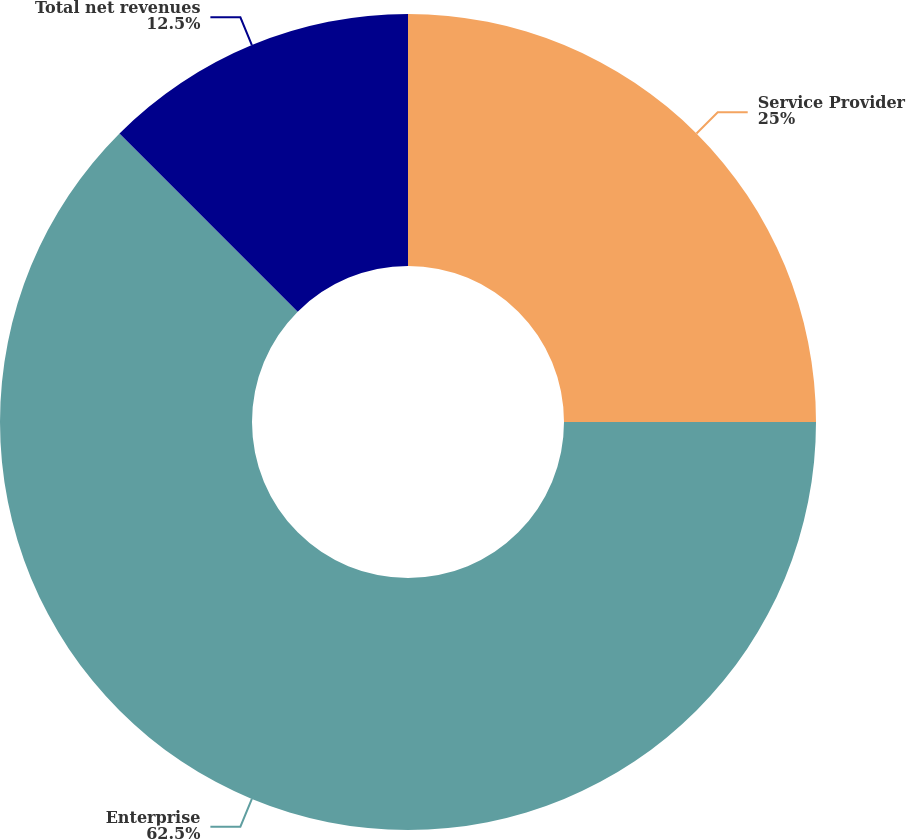Convert chart to OTSL. <chart><loc_0><loc_0><loc_500><loc_500><pie_chart><fcel>Service Provider<fcel>Enterprise<fcel>Total net revenues<nl><fcel>25.0%<fcel>62.5%<fcel>12.5%<nl></chart> 